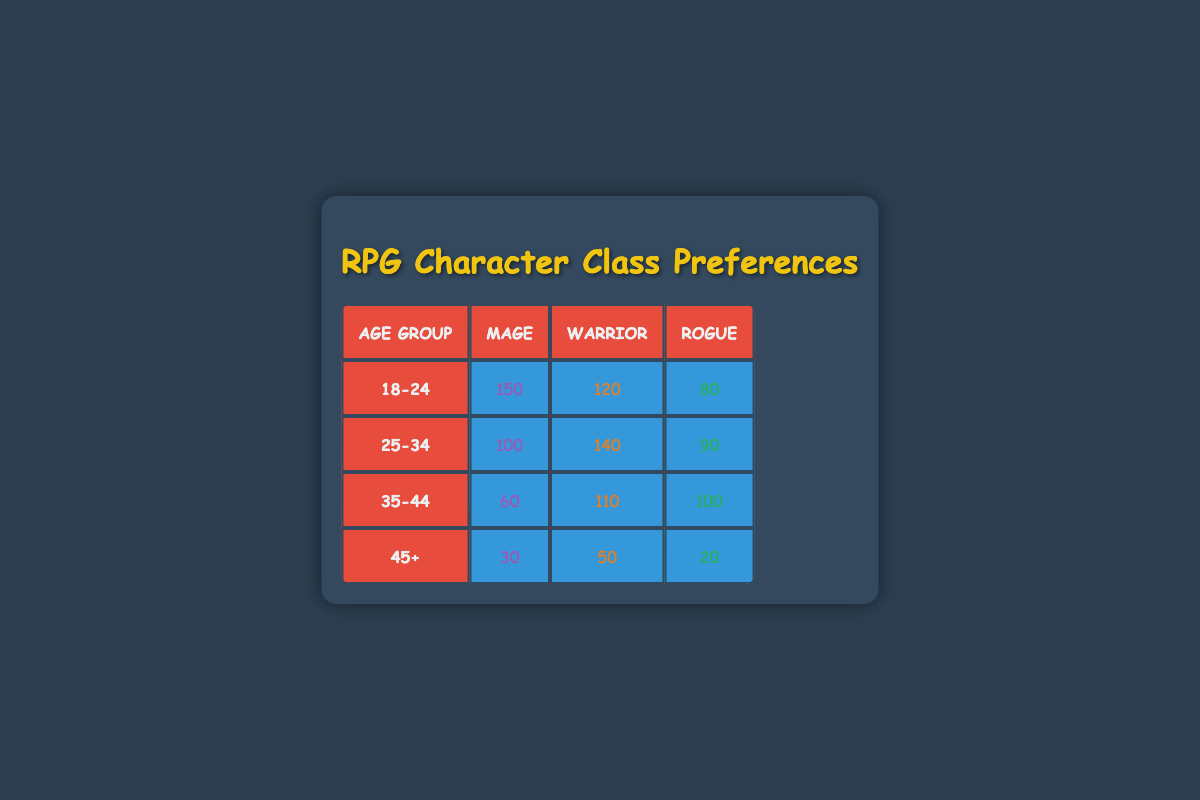What is the most popular character class among the 18-24 age group? In the 18-24 age group, the number of players for each character class is as follows: Mage 150, Warrior 120, and Rogue 80. The Mage has the highest number of players, making it the most popular class.
Answer: Mage What is the total number of players who prefer the Warrior class across all age groups? To find the total number of players who prefer the Warrior class, we need to sum the players from each age group: 120 (18-24) + 140 (25-34) + 110 (35-44) + 50 (45+) = 420.
Answer: 420 Is the Mage class more popular than the Rogue class in the 25-34 age group? In the 25-34 age group, the Mage has 100 players while the Rogue has 90 players. Since 100 is greater than 90, the Mage class is indeed more popular than the Rogue class.
Answer: Yes What is the difference in the number of players between the Mage and Warrior classes in the 35-44 age group? In the 35-44 age group, the Mage has 60 players and the Warrior has 110 players. To find the difference, we subtract the number of players for Mage from that of Warrior: 110 - 60 = 50.
Answer: 50 Which age group has the lowest number of players for the Rogue class? Looking at the Rogue class numbers, we have: 80 (18-24), 90 (25-34), 100 (35-44), and 20 (45+). The 45+ age group has the lowest number of players with just 20.
Answer: 45+ Which character class has the highest overall player preference in the data? To find the overall highest character class, we need to sum the players for each class: Mage: 150 + 100 + 60 + 30 = 340, Warrior: 120 + 140 + 110 + 50 = 420, Rogue: 80 + 90 + 100 + 20 = 290. The Warrior class has the highest total with 420 players.
Answer: Warrior Is the total number of players who prefer the Mage class less than the players who prefer the Rogue class? Totaling the Mage players gives us 150 + 100 + 60 + 30 = 340. For the Rogue, it's 80 + 90 + 100 + 20 = 290. Since 340 is greater than 290, this statement is false.
Answer: No What is the average number of players for the Warrior class across all age groups? The total number of players for the Warrior class is 420 (as calculated previously). There are 4 age groups, so the average is 420 / 4 = 105.
Answer: 105 